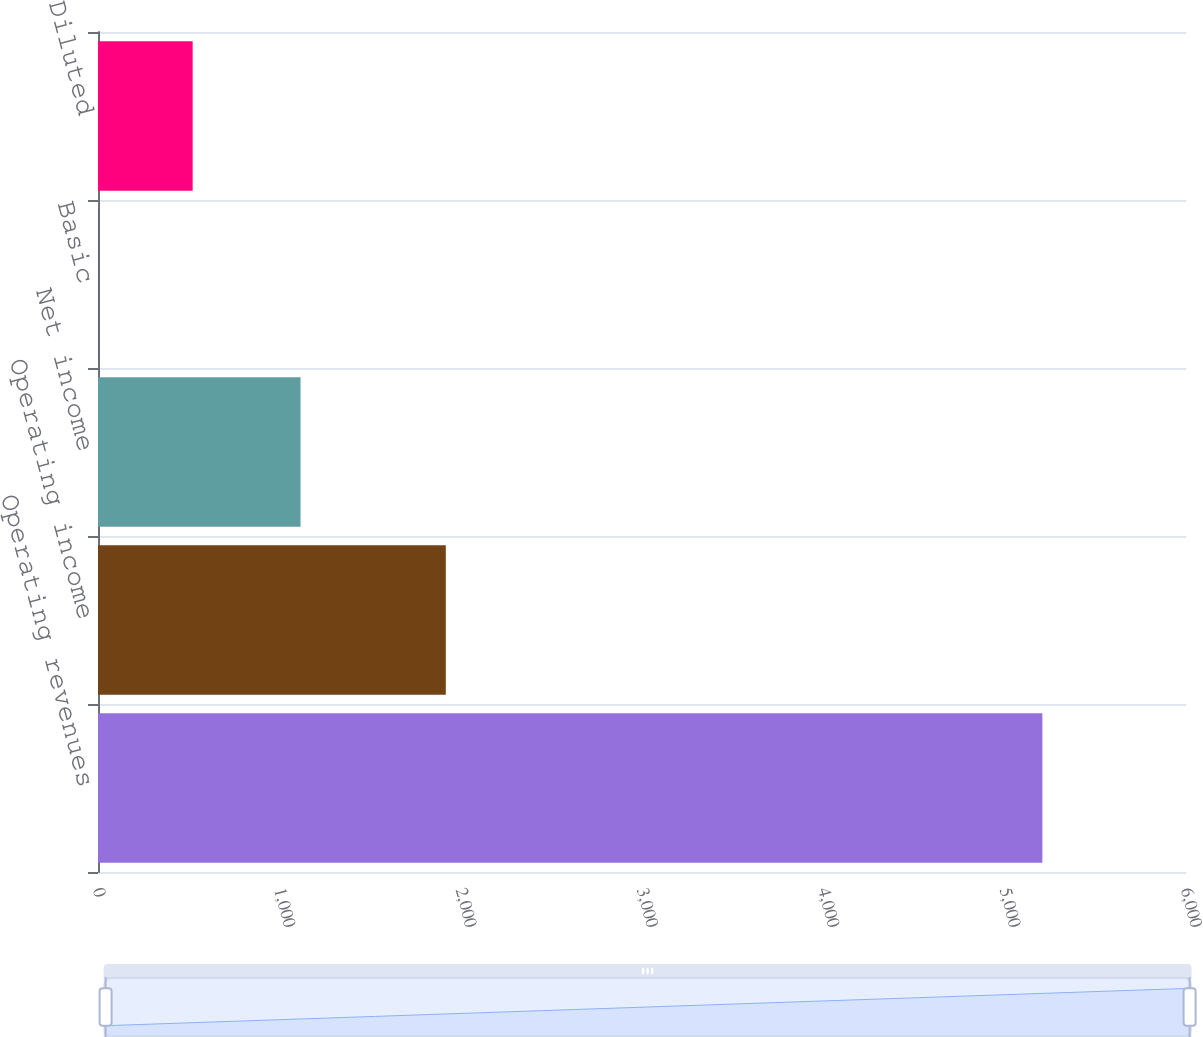Convert chart. <chart><loc_0><loc_0><loc_500><loc_500><bar_chart><fcel>Operating revenues<fcel>Operating income<fcel>Net income<fcel>Basic<fcel>Diluted<nl><fcel>5208<fcel>1918<fcel>1117<fcel>1.31<fcel>521.98<nl></chart> 